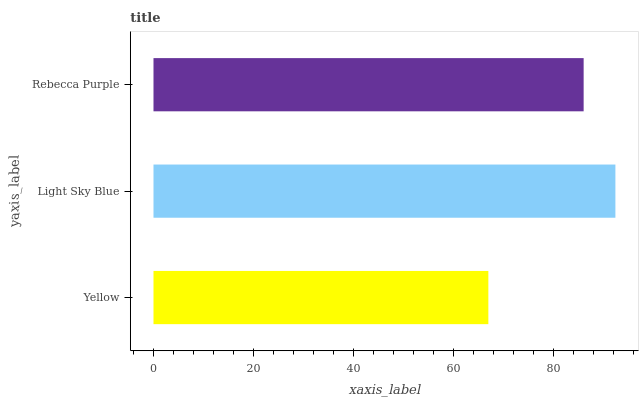Is Yellow the minimum?
Answer yes or no. Yes. Is Light Sky Blue the maximum?
Answer yes or no. Yes. Is Rebecca Purple the minimum?
Answer yes or no. No. Is Rebecca Purple the maximum?
Answer yes or no. No. Is Light Sky Blue greater than Rebecca Purple?
Answer yes or no. Yes. Is Rebecca Purple less than Light Sky Blue?
Answer yes or no. Yes. Is Rebecca Purple greater than Light Sky Blue?
Answer yes or no. No. Is Light Sky Blue less than Rebecca Purple?
Answer yes or no. No. Is Rebecca Purple the high median?
Answer yes or no. Yes. Is Rebecca Purple the low median?
Answer yes or no. Yes. Is Light Sky Blue the high median?
Answer yes or no. No. Is Yellow the low median?
Answer yes or no. No. 